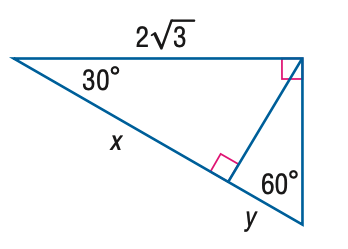Answer the mathemtical geometry problem and directly provide the correct option letter.
Question: Find x.
Choices: A: \sqrt { 3 } B: \sqrt { 6 } C: 3 D: 6 C 